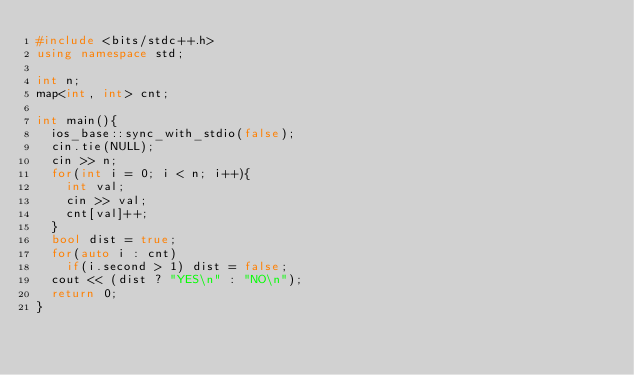<code> <loc_0><loc_0><loc_500><loc_500><_C++_>#include <bits/stdc++.h>
using namespace std;

int n;
map<int, int> cnt;

int main(){
	ios_base::sync_with_stdio(false);
	cin.tie(NULL);
	cin >> n;
	for(int i = 0; i < n; i++){
		int val;
		cin >> val;
		cnt[val]++;
	}
	bool dist = true;
	for(auto i : cnt)
		if(i.second > 1) dist = false;
	cout << (dist ? "YES\n" : "NO\n");
	return 0;
}</code> 